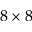Convert formula to latex. <formula><loc_0><loc_0><loc_500><loc_500>8 \times 8</formula> 